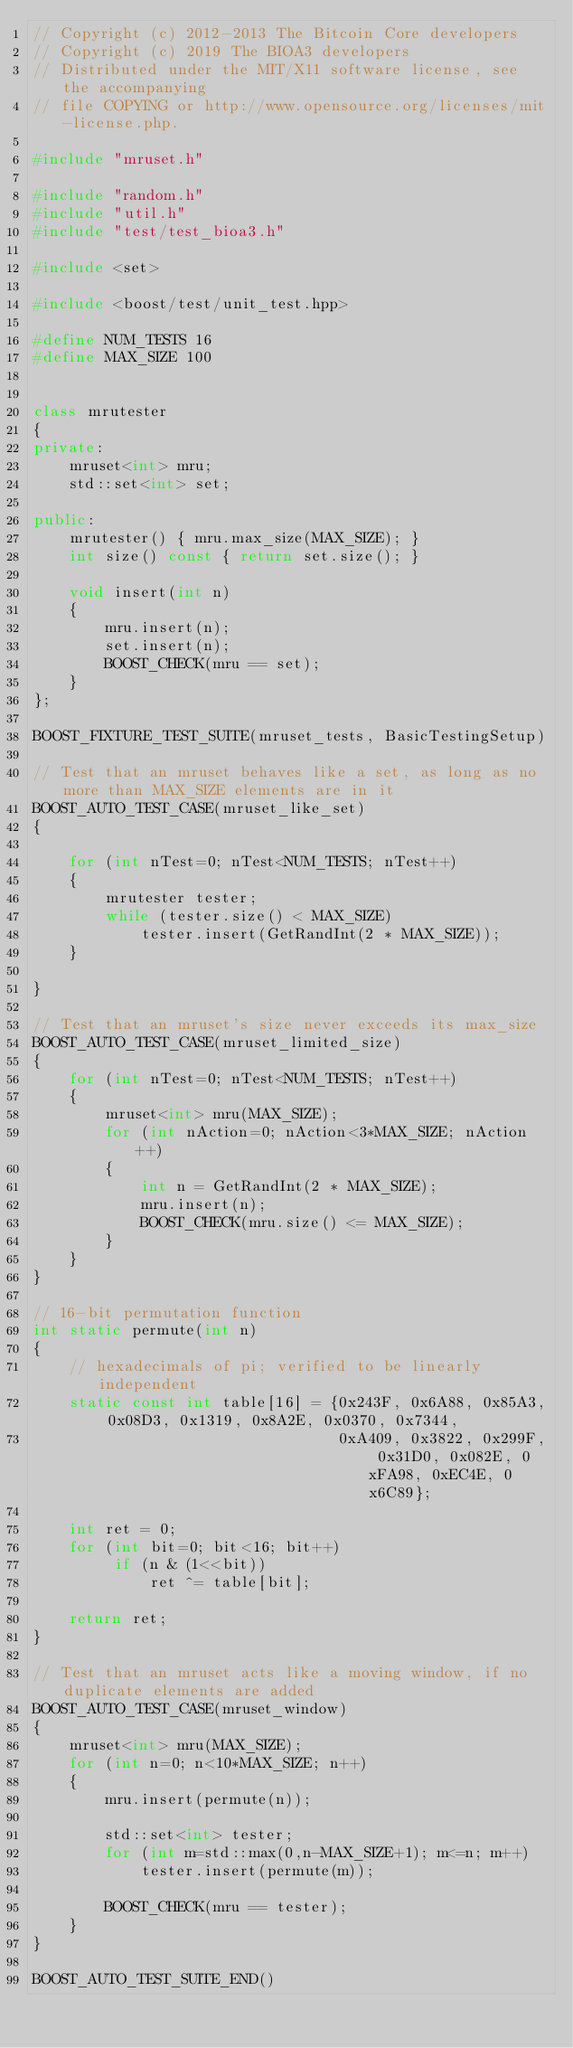<code> <loc_0><loc_0><loc_500><loc_500><_C++_>// Copyright (c) 2012-2013 The Bitcoin Core developers
// Copyright (c) 2019 The BIOA3 developers
// Distributed under the MIT/X11 software license, see the accompanying
// file COPYING or http://www.opensource.org/licenses/mit-license.php.

#include "mruset.h"

#include "random.h"
#include "util.h"
#include "test/test_bioa3.h"

#include <set>

#include <boost/test/unit_test.hpp>

#define NUM_TESTS 16
#define MAX_SIZE 100


class mrutester
{
private:
    mruset<int> mru;
    std::set<int> set;

public:
    mrutester() { mru.max_size(MAX_SIZE); }
    int size() const { return set.size(); }

    void insert(int n)
    {
        mru.insert(n);
        set.insert(n);
        BOOST_CHECK(mru == set);
    }
};

BOOST_FIXTURE_TEST_SUITE(mruset_tests, BasicTestingSetup)

// Test that an mruset behaves like a set, as long as no more than MAX_SIZE elements are in it
BOOST_AUTO_TEST_CASE(mruset_like_set)
{

    for (int nTest=0; nTest<NUM_TESTS; nTest++)
    {
        mrutester tester;
        while (tester.size() < MAX_SIZE)
            tester.insert(GetRandInt(2 * MAX_SIZE));
    }

}

// Test that an mruset's size never exceeds its max_size
BOOST_AUTO_TEST_CASE(mruset_limited_size)
{
    for (int nTest=0; nTest<NUM_TESTS; nTest++)
    {
        mruset<int> mru(MAX_SIZE);
        for (int nAction=0; nAction<3*MAX_SIZE; nAction++)
        {
            int n = GetRandInt(2 * MAX_SIZE);
            mru.insert(n);
            BOOST_CHECK(mru.size() <= MAX_SIZE);
        }
    }
}

// 16-bit permutation function
int static permute(int n)
{
    // hexadecimals of pi; verified to be linearly independent
    static const int table[16] = {0x243F, 0x6A88, 0x85A3, 0x08D3, 0x1319, 0x8A2E, 0x0370, 0x7344,
                                  0xA409, 0x3822, 0x299F, 0x31D0, 0x082E, 0xFA98, 0xEC4E, 0x6C89};

    int ret = 0;
    for (int bit=0; bit<16; bit++)
         if (n & (1<<bit))
             ret ^= table[bit];

    return ret;
}

// Test that an mruset acts like a moving window, if no duplicate elements are added
BOOST_AUTO_TEST_CASE(mruset_window)
{
    mruset<int> mru(MAX_SIZE);
    for (int n=0; n<10*MAX_SIZE; n++)
    {
        mru.insert(permute(n));

        std::set<int> tester;
        for (int m=std::max(0,n-MAX_SIZE+1); m<=n; m++)
            tester.insert(permute(m));

        BOOST_CHECK(mru == tester);
    }
}

BOOST_AUTO_TEST_SUITE_END()
</code> 